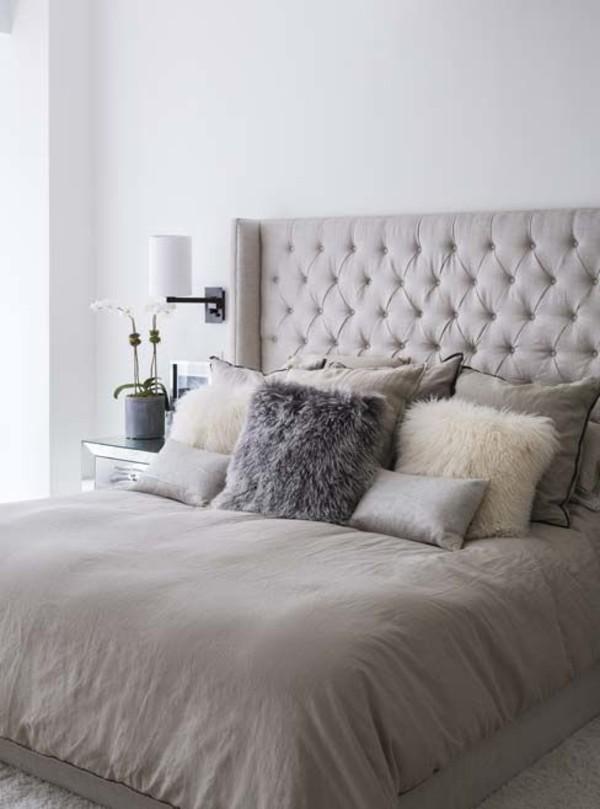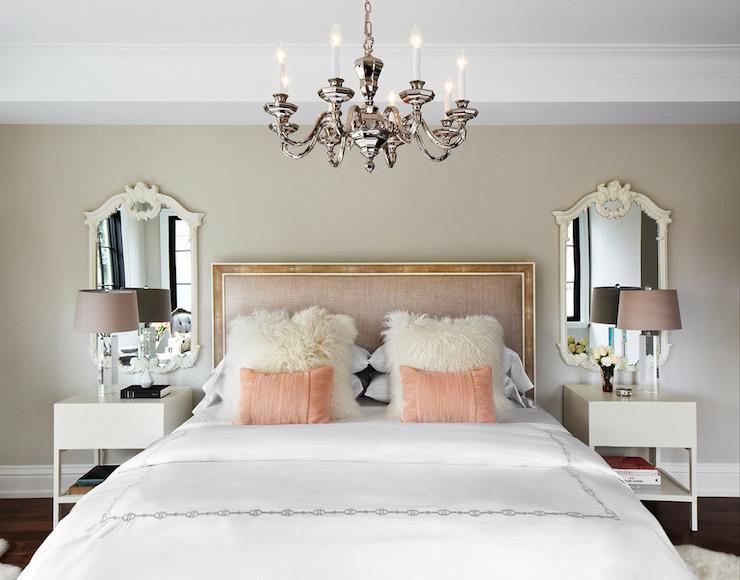The first image is the image on the left, the second image is the image on the right. Examine the images to the left and right. Is the description "In at least one image there is a bed with a light colored comforter and an arched triangle like bed board." accurate? Answer yes or no. No. The first image is the image on the left, the second image is the image on the right. Considering the images on both sides, is "The right image shows a narrow pillow centered in front of side-by-side pillows on a bed with an upholstered arch-topped headboard." valid? Answer yes or no. No. 